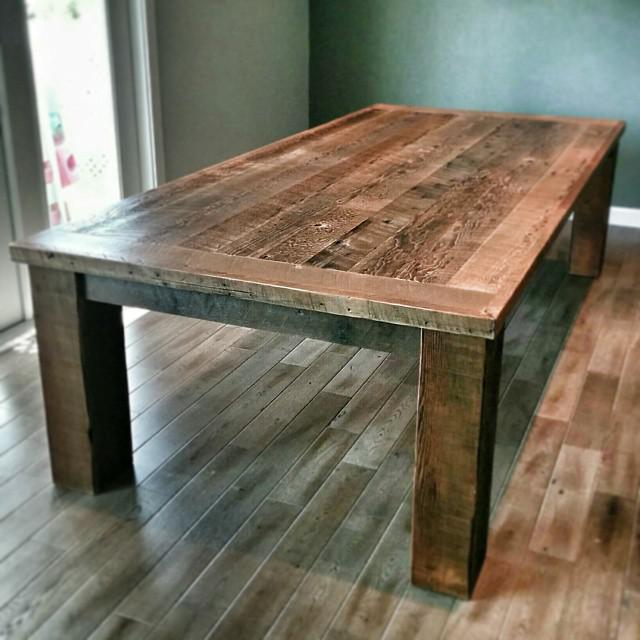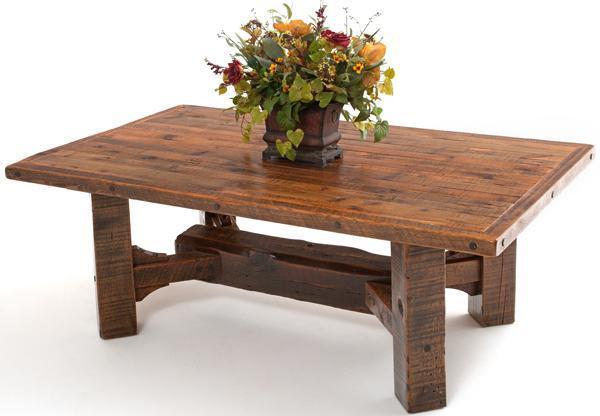The first image is the image on the left, the second image is the image on the right. Evaluate the accuracy of this statement regarding the images: "There is nothing on the table in the image on the left". Is it true? Answer yes or no. Yes. The first image is the image on the left, the second image is the image on the right. Considering the images on both sides, is "A rectangular wooden dining table is shown with at least four chairs in one image." valid? Answer yes or no. No. 